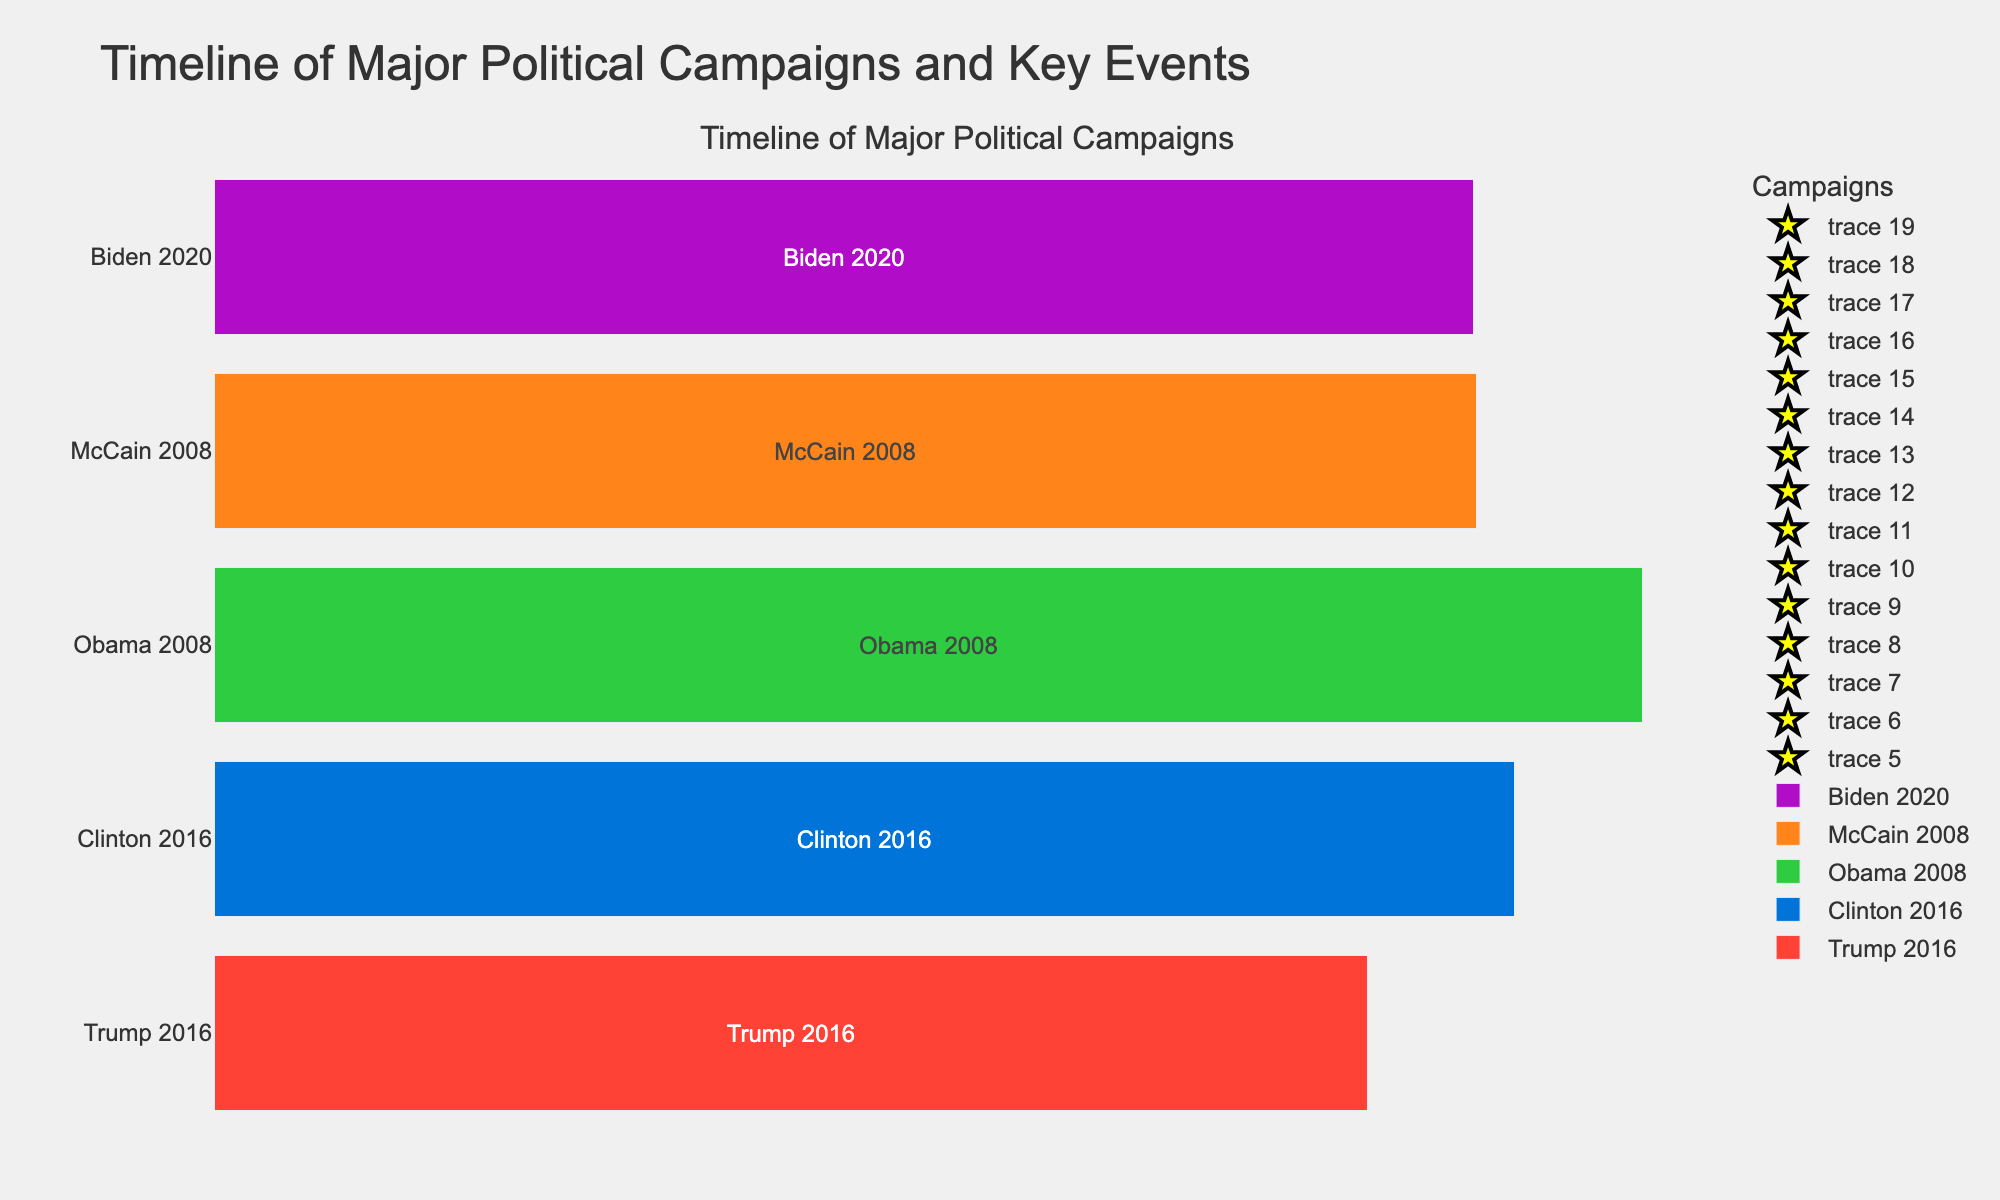When does the "Clinton 2016" campaign start and end? The "Clinton 2016" campaign timeline starts on April 12, 2015, and ends on November 8, 2016. This data can be directly observed from the campaign bar and the corresponding dates.
Answer: April 12, 2015, to November 8, 2016 Which campaign has the longest duration, and how many days does it last? By comparing the length of the bars in the figure, the "Obama 2008" campaign has the longest duration. The duration can be calculated by subtracting the start date from the end date: November 4, 2008 - February 10, 2007. This gives us 634 days.
Answer: Obama 2008, 634 days How many key events are identified in the Biden 2020 campaign? By counting the number of star markers and their associated text labels on the "Biden 2020" campaign bar, we can determine the key events. The "Biden 2020" campaign has three key events: Campaign Launch, Democratic National Convention, and Presidential Debates.
Answer: 3 How do the starting dates of the "Trump 2016" and "Clinton 2016" campaigns compare? By observing the figure, the "Trump 2016" campaign started on June 16, 2015, while the "Clinton 2016" campaign started earlier on April 12, 2015. Therefore, the "Clinton 2016" campaign started about two months before the "Trump 2016" campaign.
Answer: Clinton 2016 started earlier Which campaigns include Presidential Debates, and during what time frames were they held? By identifying the key events labeled as "Presidential Debates" in the figure, we can see that "Trump 2016", "Clinton 2016", "Obama 2008", "McCain 2008", and "Biden 2020" all include Presidential Debates. The time frames are as follows:
- Trump 2016: September 26, 2016 - October 19, 2016
- Clinton 2016: September 26, 2016 - October 19, 2016
- Obama 2008: September 26, 2008 - October 15, 2008
- McCain 2008: September 26, 2008 - October 15, 2008
- Biden 2020: September 29, 2020 - October 22, 2020
Answer: Trump 2016, Clinton 2016, Obama 2008, McCain 2008, Biden 2020 What key event is represented on July 28, 2016, and for which campaign? By identifying the star marker and text label on the "Clinton 2016" campaign bar at the position marked July 28, 2016, we can see that the key event is "Democratic National Convention" for the "Clinton 2016" campaign.
Answer: Democratic National Convention, Clinton 2016 Compare the total span of the "Biden 2020" campaign to that of the "McCain 2008" campaign. Which one is longer? The "Biden 2020" campaign starts on April 25, 2019, and ends on November 3, 2020, giving a span of 559 days. The "McCain 2008" campaign starts on April 25, 2007, and ends on November 4, 2008, giving a span of 560 days. Therefore, the "McCain 2008" campaign is longer by one day.
Answer: McCain 2008 is longer by 1 day 